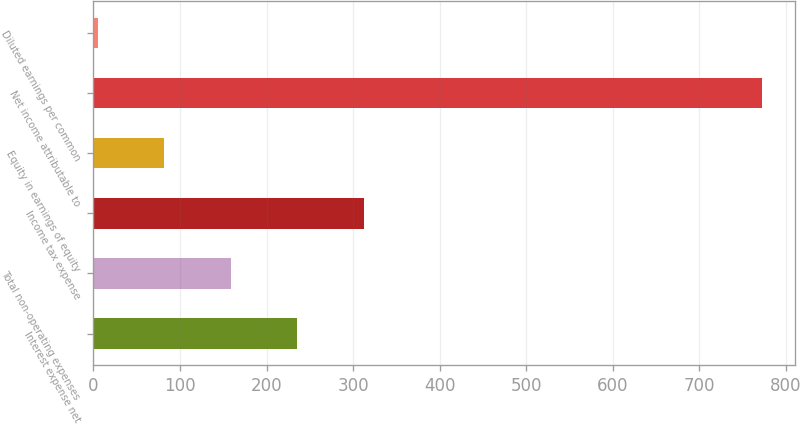Convert chart to OTSL. <chart><loc_0><loc_0><loc_500><loc_500><bar_chart><fcel>Interest expense net<fcel>Total non-operating expenses<fcel>Income tax expense<fcel>Equity in earnings of equity<fcel>Net income attributable to<fcel>Diluted earnings per common<nl><fcel>235.45<fcel>158.8<fcel>312.1<fcel>82.15<fcel>772<fcel>5.5<nl></chart> 